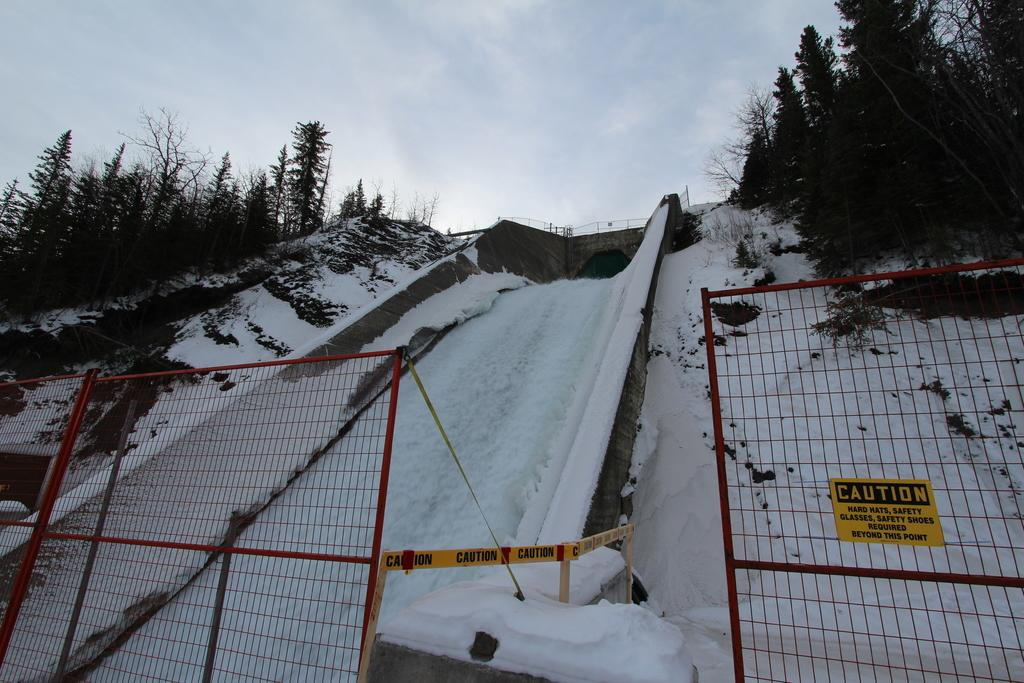What type of barrier can be seen in the image? There is a fence in the image. What is attached to the fence or nearby? There is a poster in the image. What is the weather like in the image? There is snow visible in the image, indicating a cold and likely snowy environment. What type of vegetation is present in the image? There are trees in the image. What is visible at the top of the image? The sky is visible at the top of the image. How many women are walking in the snow in the image? There are no women present in the image; it features a fence, a poster, snow, trees, and a visible sky. What type of precipitation is falling from the sky in the image? The image does not show any precipitation falling from the sky; it only shows snow that has already accumulated on the ground. 